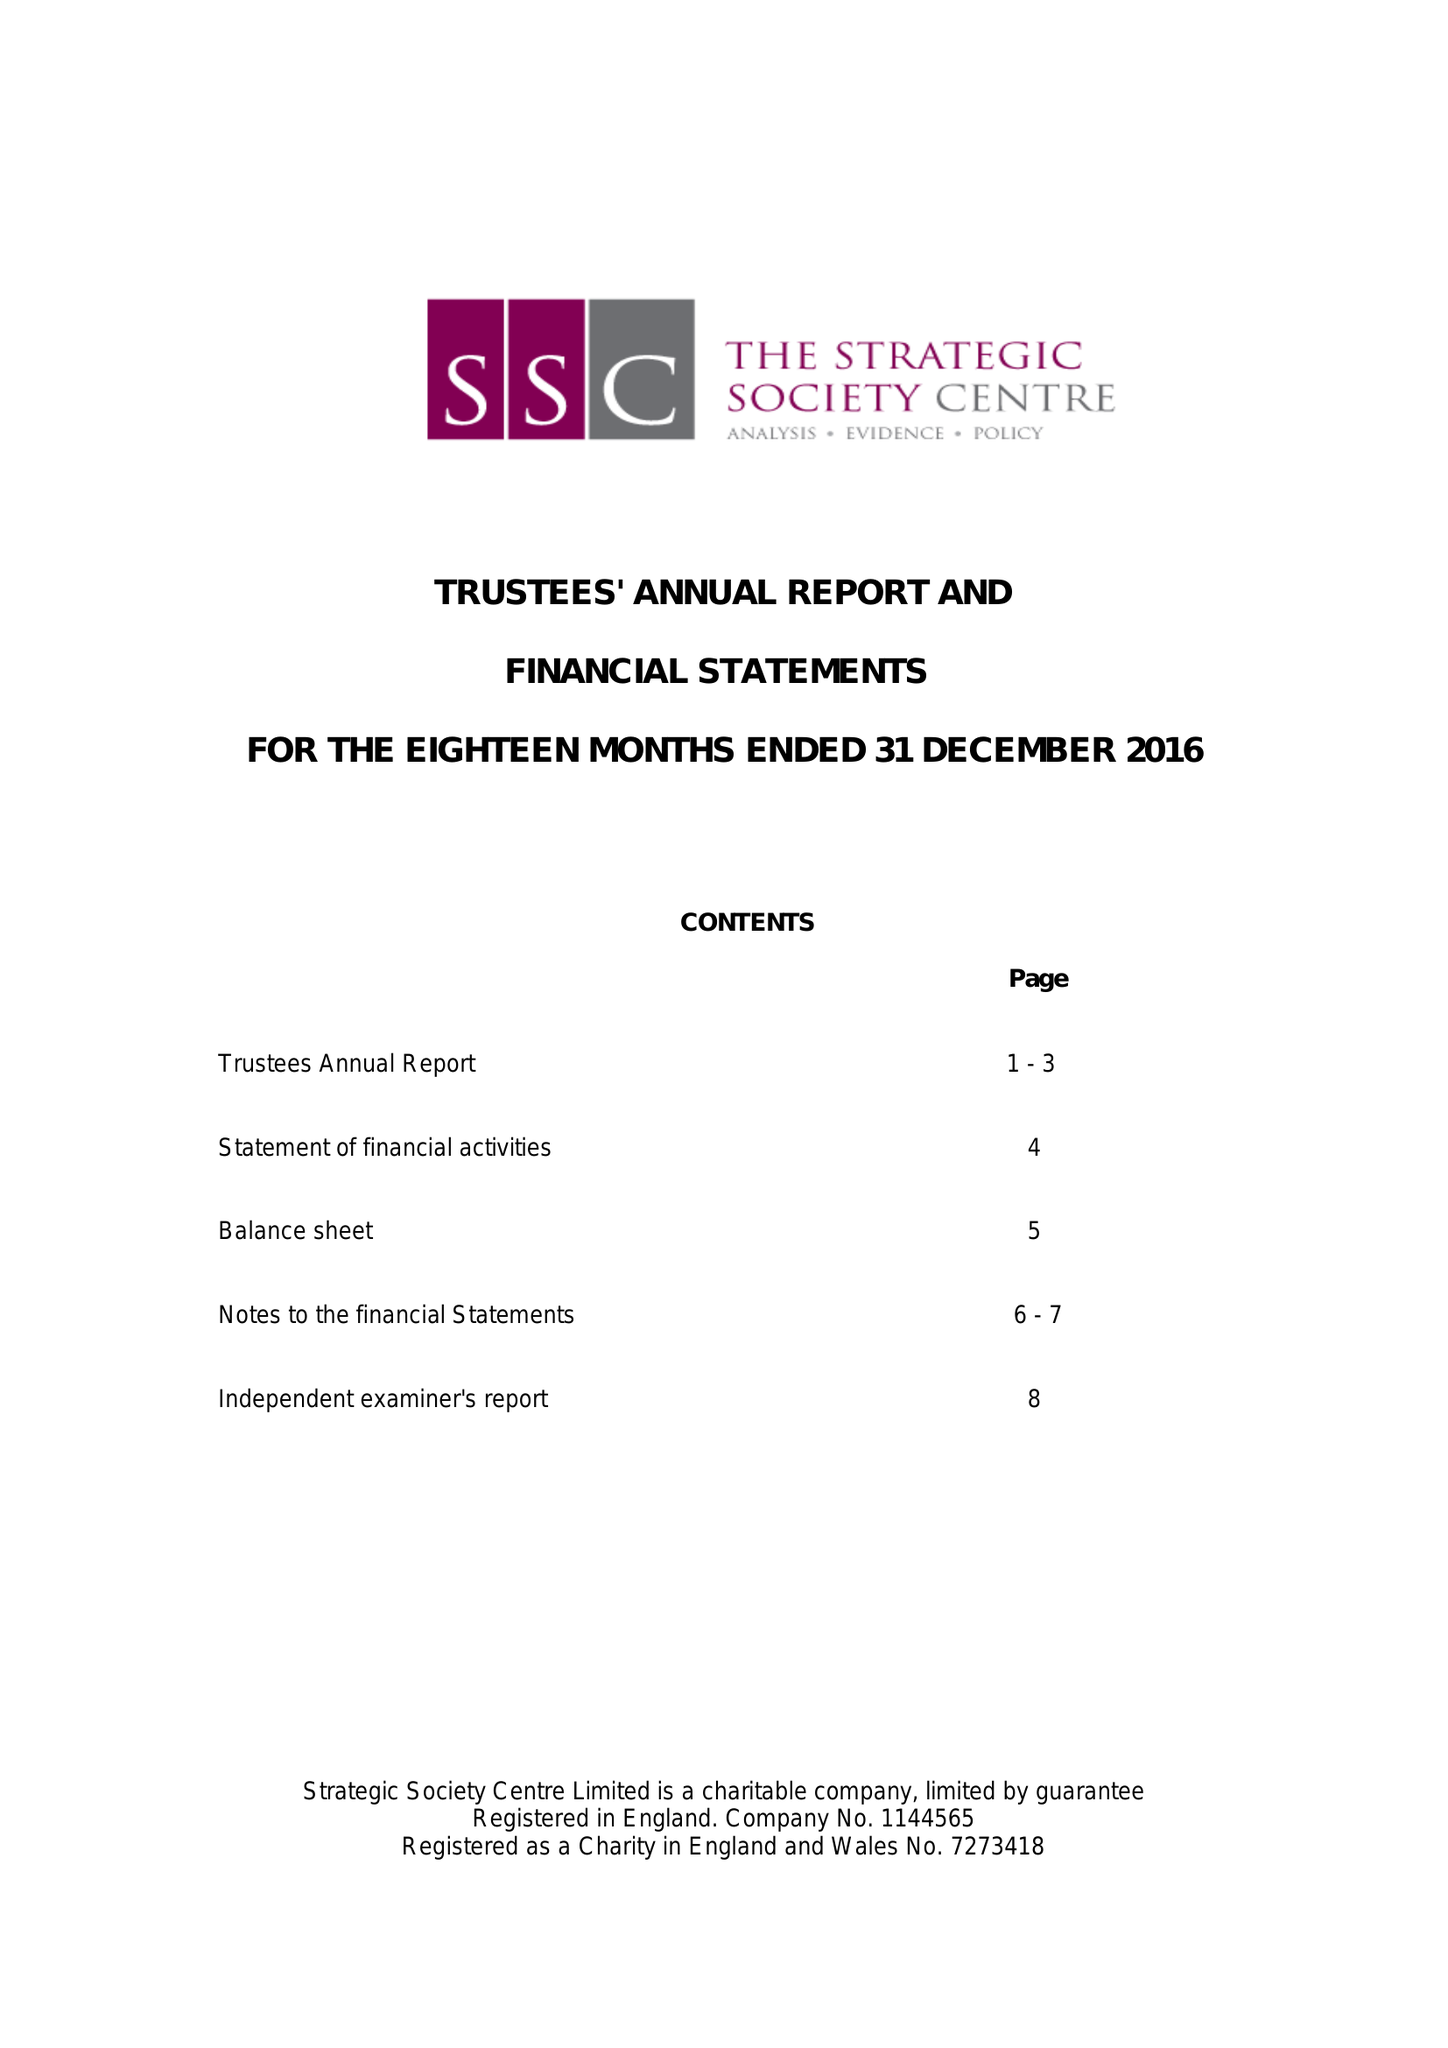What is the value for the spending_annually_in_british_pounds?
Answer the question using a single word or phrase. 64642.00 